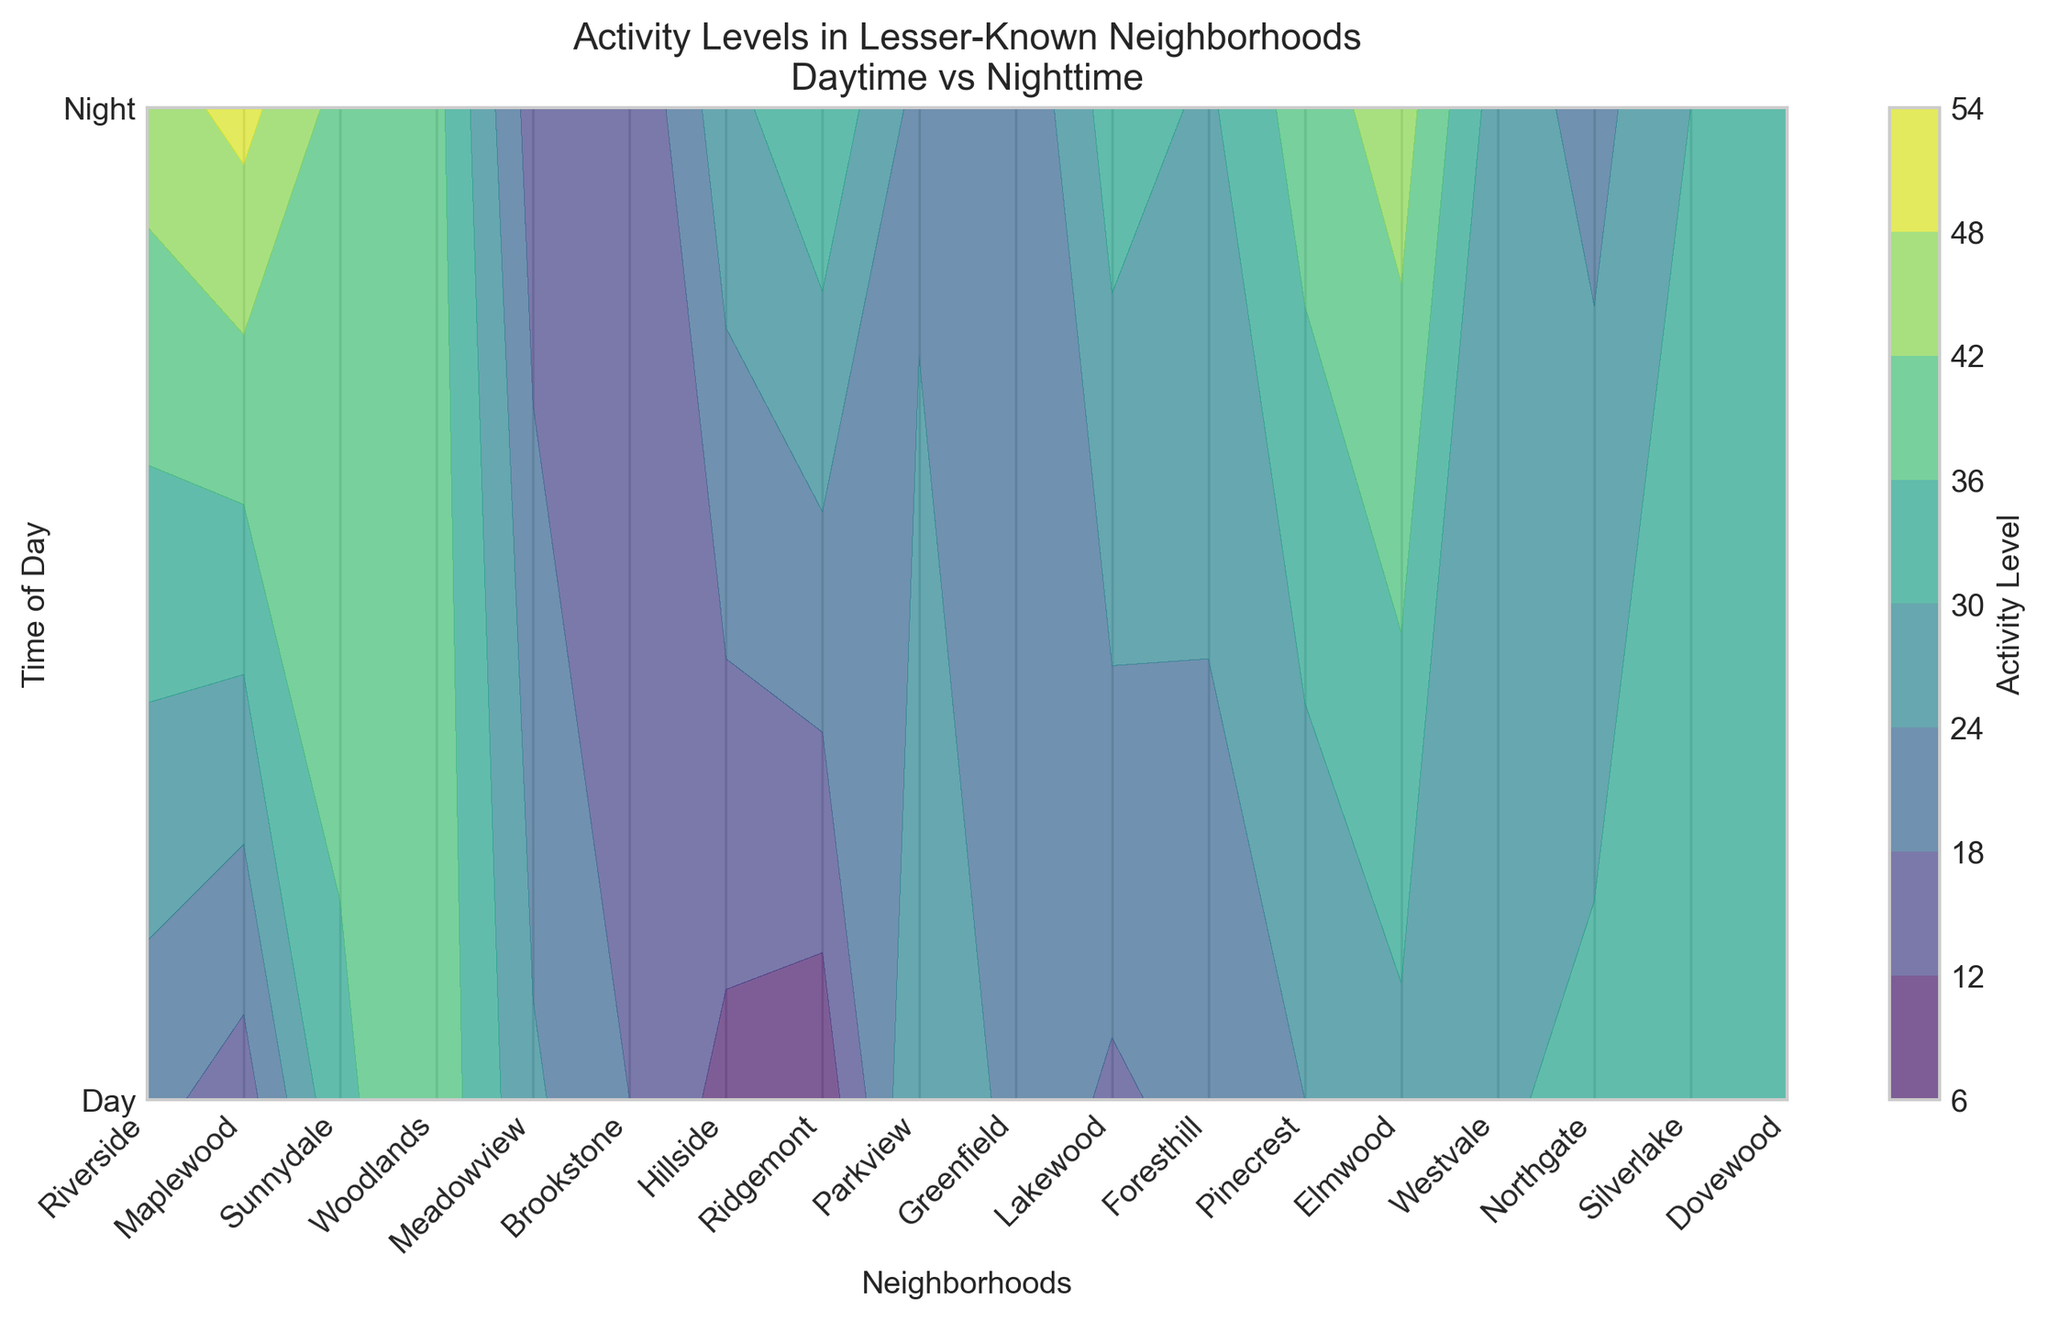What's the difference in nighttime activity levels between Northgate and Pinecrest? Northgate has a nighttime activity level of 45, and Pinecrest has a nighttime activity level of 35. The difference is 45 - 35 = 10.
Answer: 10 Which neighborhood has the highest daytime activity level, and what is it? Greenfield has the highest daytime activity level. Looking at the contour plot, Greenfield's activity level during the day is 45.
Answer: Greenfield, 45 Identify a neighborhood where the nighttime activity level is higher than the daytime activity level. Maplewood has a nighttime activity level of 40, which is higher than its daytime activity level of 35.
Answer: Maplewood Compare the daytime activity levels of Riverside and Lakewood. Which one is higher, and by how much? Riverside has a daytime activity level of 20, and Lakewood has a daytime activity level of 40. Lakewood's activity level is higher by 40 - 20 = 20.
Answer: Lakewood, 20 What's the average activity level at night across all neighborhoods? To find the average, sum the nighttime activity levels (15 + 40 + 18 + 8 + 22 + 20 + 28 + 32 + 33 + 50 + 38 + 12 + 35 + 18 + 29 + 45 + 22 + 35 = 490) and divide by the number of neighborhoods (18). The average is 490 / 18 ≈ 27.22.
Answer: 27.22 What's the total activity level for both day and night in Dovewood? Dovewood has a daytime activity level of 30 and a nighttime activity level of 35. The total activity level is 30 + 35 = 65.
Answer: 65 Between Elmwood and Westvale, which neighborhood has a lower nighttime activity level? Elmwood has a nighttime activity level of 18, while Westvale's nighttime activity level is 29. Elmwood has a lower nighttime activity level.
Answer: Elmwood Which neighborhood has the smallest difference between daytime and nighttime activity levels, and what is the difference? Foresthill has daytime and nighttime activity levels of 15 and 12, respectively. The difference is 15 - 12 = 3, the smallest difference.
Answer: Foresthill, 3 